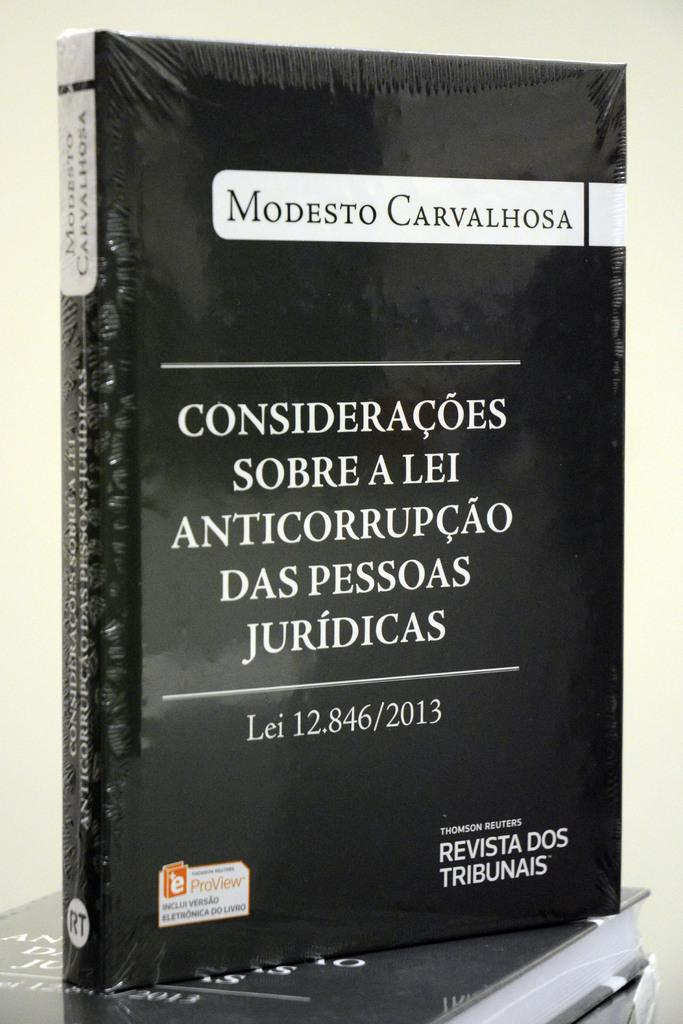What objects can be seen in the image? There are books in the image. What can be found on the books? There is text written on the books. How many rings are visible on the books in the image? There are no rings visible on the books in the image. 